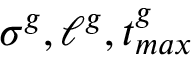Convert formula to latex. <formula><loc_0><loc_0><loc_500><loc_500>\sigma ^ { g } , \ell ^ { g } , t _ { \max } ^ { g }</formula> 